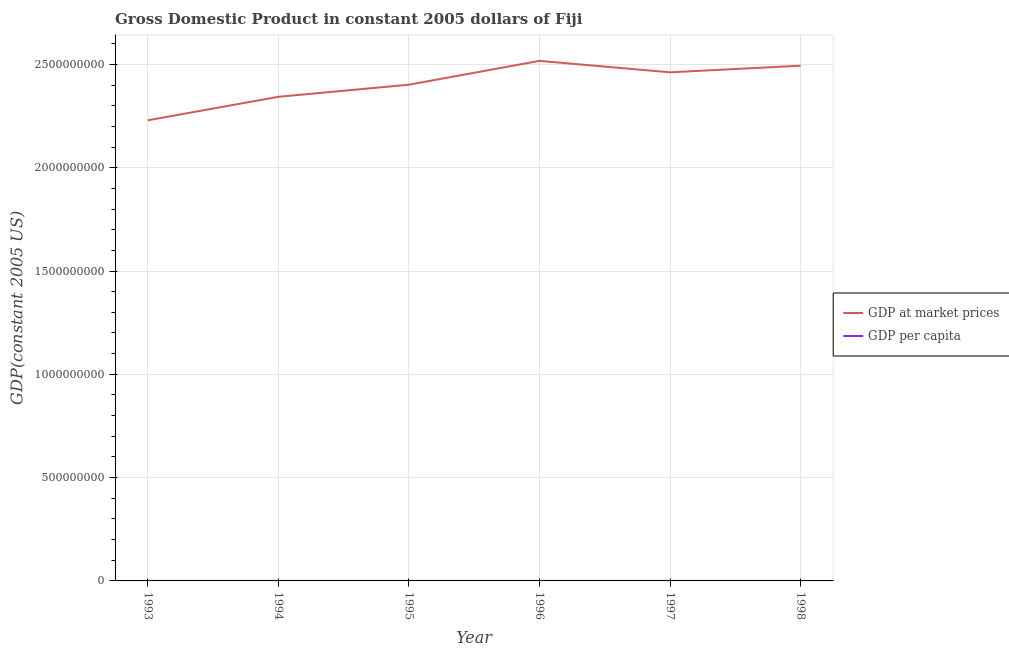Does the line corresponding to gdp at market prices intersect with the line corresponding to gdp per capita?
Provide a short and direct response. No. Is the number of lines equal to the number of legend labels?
Offer a terse response. Yes. What is the gdp at market prices in 1993?
Your response must be concise. 2.23e+09. Across all years, what is the maximum gdp per capita?
Your answer should be very brief. 3208.65. Across all years, what is the minimum gdp at market prices?
Keep it short and to the point. 2.23e+09. What is the total gdp at market prices in the graph?
Make the answer very short. 1.44e+1. What is the difference between the gdp at market prices in 1994 and that in 1998?
Offer a terse response. -1.50e+08. What is the difference between the gdp per capita in 1993 and the gdp at market prices in 1997?
Give a very brief answer. -2.46e+09. What is the average gdp at market prices per year?
Your answer should be compact. 2.41e+09. In the year 1996, what is the difference between the gdp per capita and gdp at market prices?
Provide a succinct answer. -2.52e+09. In how many years, is the gdp per capita greater than 500000000 US$?
Your response must be concise. 0. What is the ratio of the gdp per capita in 1996 to that in 1997?
Provide a short and direct response. 1.03. Is the gdp per capita in 1994 less than that in 1996?
Provide a succinct answer. Yes. What is the difference between the highest and the second highest gdp at market prices?
Give a very brief answer. 2.34e+07. What is the difference between the highest and the lowest gdp per capita?
Keep it short and to the point. 255.71. Is the sum of the gdp at market prices in 1994 and 1996 greater than the maximum gdp per capita across all years?
Offer a terse response. Yes. Is the gdp per capita strictly greater than the gdp at market prices over the years?
Give a very brief answer. No. Is the gdp per capita strictly less than the gdp at market prices over the years?
Provide a short and direct response. Yes. How many years are there in the graph?
Your response must be concise. 6. Does the graph contain any zero values?
Give a very brief answer. No. Where does the legend appear in the graph?
Your response must be concise. Center right. How many legend labels are there?
Your answer should be compact. 2. What is the title of the graph?
Keep it short and to the point. Gross Domestic Product in constant 2005 dollars of Fiji. What is the label or title of the X-axis?
Provide a succinct answer. Year. What is the label or title of the Y-axis?
Give a very brief answer. GDP(constant 2005 US). What is the GDP(constant 2005 US) in GDP at market prices in 1993?
Make the answer very short. 2.23e+09. What is the GDP(constant 2005 US) of GDP per capita in 1993?
Provide a succinct answer. 2952.94. What is the GDP(constant 2005 US) in GDP at market prices in 1994?
Your response must be concise. 2.34e+09. What is the GDP(constant 2005 US) of GDP per capita in 1994?
Offer a terse response. 3060.41. What is the GDP(constant 2005 US) in GDP at market prices in 1995?
Your answer should be very brief. 2.40e+09. What is the GDP(constant 2005 US) in GDP per capita in 1995?
Ensure brevity in your answer.  3097.15. What is the GDP(constant 2005 US) in GDP at market prices in 1996?
Ensure brevity in your answer.  2.52e+09. What is the GDP(constant 2005 US) of GDP per capita in 1996?
Provide a succinct answer. 3208.65. What is the GDP(constant 2005 US) in GDP at market prices in 1997?
Offer a very short reply. 2.46e+09. What is the GDP(constant 2005 US) of GDP per capita in 1997?
Provide a short and direct response. 3104.89. What is the GDP(constant 2005 US) of GDP at market prices in 1998?
Make the answer very short. 2.49e+09. What is the GDP(constant 2005 US) in GDP per capita in 1998?
Provide a short and direct response. 3115.96. Across all years, what is the maximum GDP(constant 2005 US) in GDP at market prices?
Provide a short and direct response. 2.52e+09. Across all years, what is the maximum GDP(constant 2005 US) in GDP per capita?
Make the answer very short. 3208.65. Across all years, what is the minimum GDP(constant 2005 US) of GDP at market prices?
Your response must be concise. 2.23e+09. Across all years, what is the minimum GDP(constant 2005 US) in GDP per capita?
Offer a terse response. 2952.94. What is the total GDP(constant 2005 US) of GDP at market prices in the graph?
Your answer should be compact. 1.44e+1. What is the total GDP(constant 2005 US) of GDP per capita in the graph?
Your answer should be very brief. 1.85e+04. What is the difference between the GDP(constant 2005 US) of GDP at market prices in 1993 and that in 1994?
Offer a terse response. -1.14e+08. What is the difference between the GDP(constant 2005 US) of GDP per capita in 1993 and that in 1994?
Your answer should be compact. -107.46. What is the difference between the GDP(constant 2005 US) of GDP at market prices in 1993 and that in 1995?
Offer a very short reply. -1.72e+08. What is the difference between the GDP(constant 2005 US) in GDP per capita in 1993 and that in 1995?
Ensure brevity in your answer.  -144.2. What is the difference between the GDP(constant 2005 US) in GDP at market prices in 1993 and that in 1996?
Make the answer very short. -2.88e+08. What is the difference between the GDP(constant 2005 US) in GDP per capita in 1993 and that in 1996?
Keep it short and to the point. -255.71. What is the difference between the GDP(constant 2005 US) in GDP at market prices in 1993 and that in 1997?
Keep it short and to the point. -2.32e+08. What is the difference between the GDP(constant 2005 US) in GDP per capita in 1993 and that in 1997?
Offer a very short reply. -151.95. What is the difference between the GDP(constant 2005 US) of GDP at market prices in 1993 and that in 1998?
Provide a short and direct response. -2.64e+08. What is the difference between the GDP(constant 2005 US) in GDP per capita in 1993 and that in 1998?
Your answer should be very brief. -163.01. What is the difference between the GDP(constant 2005 US) in GDP at market prices in 1994 and that in 1995?
Offer a terse response. -5.86e+07. What is the difference between the GDP(constant 2005 US) of GDP per capita in 1994 and that in 1995?
Make the answer very short. -36.74. What is the difference between the GDP(constant 2005 US) in GDP at market prices in 1994 and that in 1996?
Offer a very short reply. -1.74e+08. What is the difference between the GDP(constant 2005 US) in GDP per capita in 1994 and that in 1996?
Your answer should be very brief. -148.24. What is the difference between the GDP(constant 2005 US) of GDP at market prices in 1994 and that in 1997?
Provide a short and direct response. -1.18e+08. What is the difference between the GDP(constant 2005 US) of GDP per capita in 1994 and that in 1997?
Make the answer very short. -44.49. What is the difference between the GDP(constant 2005 US) in GDP at market prices in 1994 and that in 1998?
Ensure brevity in your answer.  -1.50e+08. What is the difference between the GDP(constant 2005 US) in GDP per capita in 1994 and that in 1998?
Keep it short and to the point. -55.55. What is the difference between the GDP(constant 2005 US) in GDP at market prices in 1995 and that in 1996?
Your answer should be compact. -1.15e+08. What is the difference between the GDP(constant 2005 US) in GDP per capita in 1995 and that in 1996?
Make the answer very short. -111.5. What is the difference between the GDP(constant 2005 US) in GDP at market prices in 1995 and that in 1997?
Give a very brief answer. -5.99e+07. What is the difference between the GDP(constant 2005 US) of GDP per capita in 1995 and that in 1997?
Offer a very short reply. -7.75. What is the difference between the GDP(constant 2005 US) of GDP at market prices in 1995 and that in 1998?
Provide a short and direct response. -9.19e+07. What is the difference between the GDP(constant 2005 US) in GDP per capita in 1995 and that in 1998?
Your response must be concise. -18.81. What is the difference between the GDP(constant 2005 US) of GDP at market prices in 1996 and that in 1997?
Provide a short and direct response. 5.54e+07. What is the difference between the GDP(constant 2005 US) of GDP per capita in 1996 and that in 1997?
Provide a succinct answer. 103.76. What is the difference between the GDP(constant 2005 US) of GDP at market prices in 1996 and that in 1998?
Ensure brevity in your answer.  2.34e+07. What is the difference between the GDP(constant 2005 US) in GDP per capita in 1996 and that in 1998?
Keep it short and to the point. 92.69. What is the difference between the GDP(constant 2005 US) of GDP at market prices in 1997 and that in 1998?
Make the answer very short. -3.20e+07. What is the difference between the GDP(constant 2005 US) of GDP per capita in 1997 and that in 1998?
Your response must be concise. -11.07. What is the difference between the GDP(constant 2005 US) in GDP at market prices in 1993 and the GDP(constant 2005 US) in GDP per capita in 1994?
Your answer should be very brief. 2.23e+09. What is the difference between the GDP(constant 2005 US) of GDP at market prices in 1993 and the GDP(constant 2005 US) of GDP per capita in 1995?
Offer a terse response. 2.23e+09. What is the difference between the GDP(constant 2005 US) of GDP at market prices in 1993 and the GDP(constant 2005 US) of GDP per capita in 1996?
Your answer should be very brief. 2.23e+09. What is the difference between the GDP(constant 2005 US) in GDP at market prices in 1993 and the GDP(constant 2005 US) in GDP per capita in 1997?
Provide a short and direct response. 2.23e+09. What is the difference between the GDP(constant 2005 US) in GDP at market prices in 1993 and the GDP(constant 2005 US) in GDP per capita in 1998?
Provide a short and direct response. 2.23e+09. What is the difference between the GDP(constant 2005 US) of GDP at market prices in 1994 and the GDP(constant 2005 US) of GDP per capita in 1995?
Provide a short and direct response. 2.34e+09. What is the difference between the GDP(constant 2005 US) of GDP at market prices in 1994 and the GDP(constant 2005 US) of GDP per capita in 1996?
Ensure brevity in your answer.  2.34e+09. What is the difference between the GDP(constant 2005 US) of GDP at market prices in 1994 and the GDP(constant 2005 US) of GDP per capita in 1997?
Provide a short and direct response. 2.34e+09. What is the difference between the GDP(constant 2005 US) of GDP at market prices in 1994 and the GDP(constant 2005 US) of GDP per capita in 1998?
Provide a succinct answer. 2.34e+09. What is the difference between the GDP(constant 2005 US) in GDP at market prices in 1995 and the GDP(constant 2005 US) in GDP per capita in 1996?
Offer a very short reply. 2.40e+09. What is the difference between the GDP(constant 2005 US) in GDP at market prices in 1995 and the GDP(constant 2005 US) in GDP per capita in 1997?
Your answer should be very brief. 2.40e+09. What is the difference between the GDP(constant 2005 US) of GDP at market prices in 1995 and the GDP(constant 2005 US) of GDP per capita in 1998?
Your answer should be compact. 2.40e+09. What is the difference between the GDP(constant 2005 US) of GDP at market prices in 1996 and the GDP(constant 2005 US) of GDP per capita in 1997?
Your answer should be compact. 2.52e+09. What is the difference between the GDP(constant 2005 US) in GDP at market prices in 1996 and the GDP(constant 2005 US) in GDP per capita in 1998?
Give a very brief answer. 2.52e+09. What is the difference between the GDP(constant 2005 US) of GDP at market prices in 1997 and the GDP(constant 2005 US) of GDP per capita in 1998?
Your answer should be compact. 2.46e+09. What is the average GDP(constant 2005 US) of GDP at market prices per year?
Your answer should be compact. 2.41e+09. What is the average GDP(constant 2005 US) in GDP per capita per year?
Give a very brief answer. 3090. In the year 1993, what is the difference between the GDP(constant 2005 US) of GDP at market prices and GDP(constant 2005 US) of GDP per capita?
Provide a short and direct response. 2.23e+09. In the year 1994, what is the difference between the GDP(constant 2005 US) in GDP at market prices and GDP(constant 2005 US) in GDP per capita?
Give a very brief answer. 2.34e+09. In the year 1995, what is the difference between the GDP(constant 2005 US) in GDP at market prices and GDP(constant 2005 US) in GDP per capita?
Offer a terse response. 2.40e+09. In the year 1996, what is the difference between the GDP(constant 2005 US) of GDP at market prices and GDP(constant 2005 US) of GDP per capita?
Ensure brevity in your answer.  2.52e+09. In the year 1997, what is the difference between the GDP(constant 2005 US) of GDP at market prices and GDP(constant 2005 US) of GDP per capita?
Provide a succinct answer. 2.46e+09. In the year 1998, what is the difference between the GDP(constant 2005 US) in GDP at market prices and GDP(constant 2005 US) in GDP per capita?
Your answer should be compact. 2.49e+09. What is the ratio of the GDP(constant 2005 US) in GDP at market prices in 1993 to that in 1994?
Your answer should be compact. 0.95. What is the ratio of the GDP(constant 2005 US) of GDP per capita in 1993 to that in 1994?
Your answer should be very brief. 0.96. What is the ratio of the GDP(constant 2005 US) of GDP at market prices in 1993 to that in 1995?
Make the answer very short. 0.93. What is the ratio of the GDP(constant 2005 US) of GDP per capita in 1993 to that in 1995?
Offer a terse response. 0.95. What is the ratio of the GDP(constant 2005 US) of GDP at market prices in 1993 to that in 1996?
Provide a short and direct response. 0.89. What is the ratio of the GDP(constant 2005 US) in GDP per capita in 1993 to that in 1996?
Ensure brevity in your answer.  0.92. What is the ratio of the GDP(constant 2005 US) in GDP at market prices in 1993 to that in 1997?
Your answer should be compact. 0.91. What is the ratio of the GDP(constant 2005 US) in GDP per capita in 1993 to that in 1997?
Offer a very short reply. 0.95. What is the ratio of the GDP(constant 2005 US) of GDP at market prices in 1993 to that in 1998?
Give a very brief answer. 0.89. What is the ratio of the GDP(constant 2005 US) of GDP per capita in 1993 to that in 1998?
Keep it short and to the point. 0.95. What is the ratio of the GDP(constant 2005 US) of GDP at market prices in 1994 to that in 1995?
Offer a terse response. 0.98. What is the ratio of the GDP(constant 2005 US) in GDP per capita in 1994 to that in 1995?
Provide a short and direct response. 0.99. What is the ratio of the GDP(constant 2005 US) in GDP at market prices in 1994 to that in 1996?
Offer a very short reply. 0.93. What is the ratio of the GDP(constant 2005 US) of GDP per capita in 1994 to that in 1996?
Your response must be concise. 0.95. What is the ratio of the GDP(constant 2005 US) in GDP at market prices in 1994 to that in 1997?
Make the answer very short. 0.95. What is the ratio of the GDP(constant 2005 US) in GDP per capita in 1994 to that in 1997?
Your answer should be very brief. 0.99. What is the ratio of the GDP(constant 2005 US) in GDP at market prices in 1994 to that in 1998?
Offer a terse response. 0.94. What is the ratio of the GDP(constant 2005 US) of GDP per capita in 1994 to that in 1998?
Offer a very short reply. 0.98. What is the ratio of the GDP(constant 2005 US) of GDP at market prices in 1995 to that in 1996?
Give a very brief answer. 0.95. What is the ratio of the GDP(constant 2005 US) in GDP per capita in 1995 to that in 1996?
Your response must be concise. 0.97. What is the ratio of the GDP(constant 2005 US) in GDP at market prices in 1995 to that in 1997?
Provide a succinct answer. 0.98. What is the ratio of the GDP(constant 2005 US) of GDP per capita in 1995 to that in 1997?
Your response must be concise. 1. What is the ratio of the GDP(constant 2005 US) in GDP at market prices in 1995 to that in 1998?
Your answer should be very brief. 0.96. What is the ratio of the GDP(constant 2005 US) in GDP at market prices in 1996 to that in 1997?
Offer a very short reply. 1.02. What is the ratio of the GDP(constant 2005 US) of GDP per capita in 1996 to that in 1997?
Your answer should be very brief. 1.03. What is the ratio of the GDP(constant 2005 US) of GDP at market prices in 1996 to that in 1998?
Keep it short and to the point. 1.01. What is the ratio of the GDP(constant 2005 US) in GDP per capita in 1996 to that in 1998?
Offer a very short reply. 1.03. What is the ratio of the GDP(constant 2005 US) in GDP at market prices in 1997 to that in 1998?
Your answer should be very brief. 0.99. What is the ratio of the GDP(constant 2005 US) in GDP per capita in 1997 to that in 1998?
Make the answer very short. 1. What is the difference between the highest and the second highest GDP(constant 2005 US) of GDP at market prices?
Your answer should be compact. 2.34e+07. What is the difference between the highest and the second highest GDP(constant 2005 US) in GDP per capita?
Your answer should be very brief. 92.69. What is the difference between the highest and the lowest GDP(constant 2005 US) of GDP at market prices?
Offer a very short reply. 2.88e+08. What is the difference between the highest and the lowest GDP(constant 2005 US) in GDP per capita?
Your response must be concise. 255.71. 